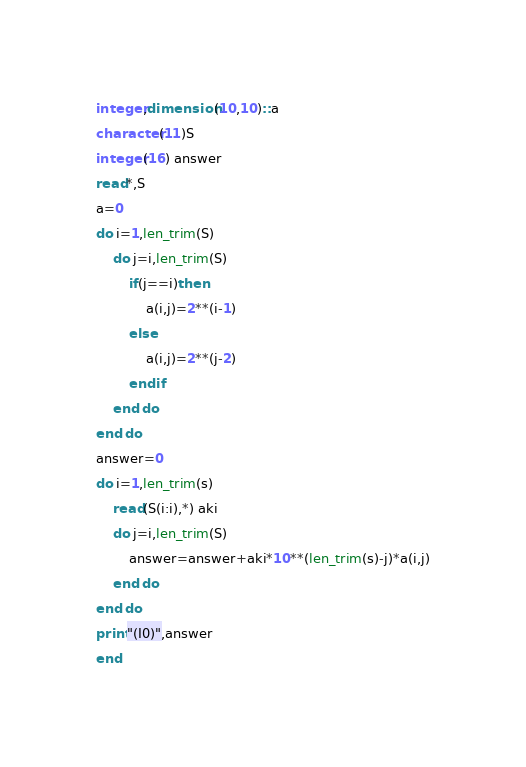<code> <loc_0><loc_0><loc_500><loc_500><_FORTRAN_>integer,dimension(10,10)::a
character(11)S
integer(16) answer
read*,S
a=0
do i=1,len_trim(S)
	do j=i,len_trim(S)
    	if(j==i)then
        	a(i,j)=2**(i-1)
        else
        	a(i,j)=2**(j-2)
        endif
    end do
end do
answer=0
do i=1,len_trim(s)
	read(S(i:i),*) aki
    do j=i,len_trim(S)
    	answer=answer+aki*10**(len_trim(s)-j)*a(i,j)
    end do
end do
print"(I0)",answer
end
</code> 